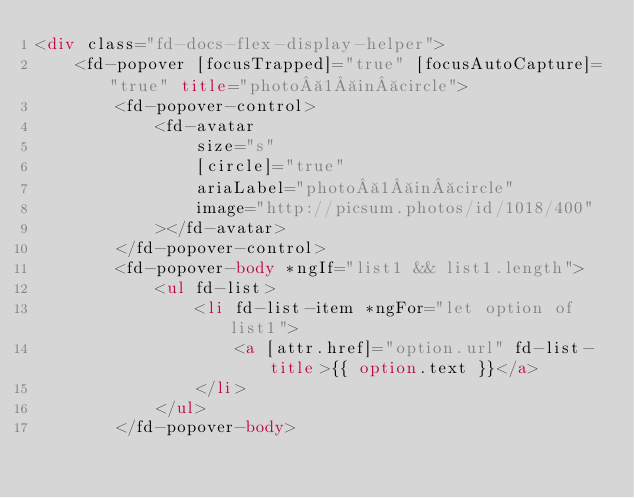Convert code to text. <code><loc_0><loc_0><loc_500><loc_500><_HTML_><div class="fd-docs-flex-display-helper">
    <fd-popover [focusTrapped]="true" [focusAutoCapture]="true" title="photo 1 in circle">
        <fd-popover-control>
            <fd-avatar
                size="s"
                [circle]="true"
                ariaLabel="photo 1 in circle"
                image="http://picsum.photos/id/1018/400"
            ></fd-avatar>
        </fd-popover-control>
        <fd-popover-body *ngIf="list1 && list1.length">
            <ul fd-list>
                <li fd-list-item *ngFor="let option of list1">
                    <a [attr.href]="option.url" fd-list-title>{{ option.text }}</a>
                </li>
            </ul>
        </fd-popover-body></code> 